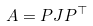<formula> <loc_0><loc_0><loc_500><loc_500>A = P J P ^ { \top }</formula> 